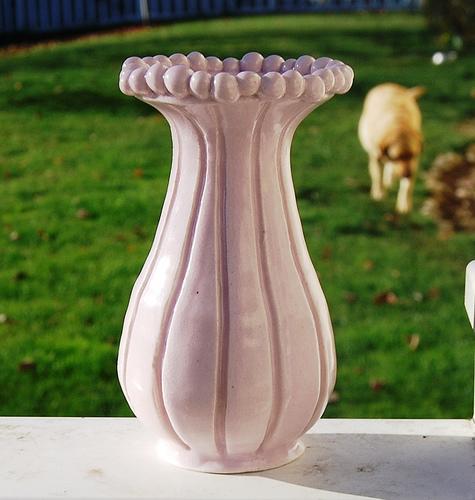How many curved lines are on this item?
Quick response, please. 5. Are there flowers in the vase?
Short answer required. No. What is cast?
Give a very brief answer. Vase. 